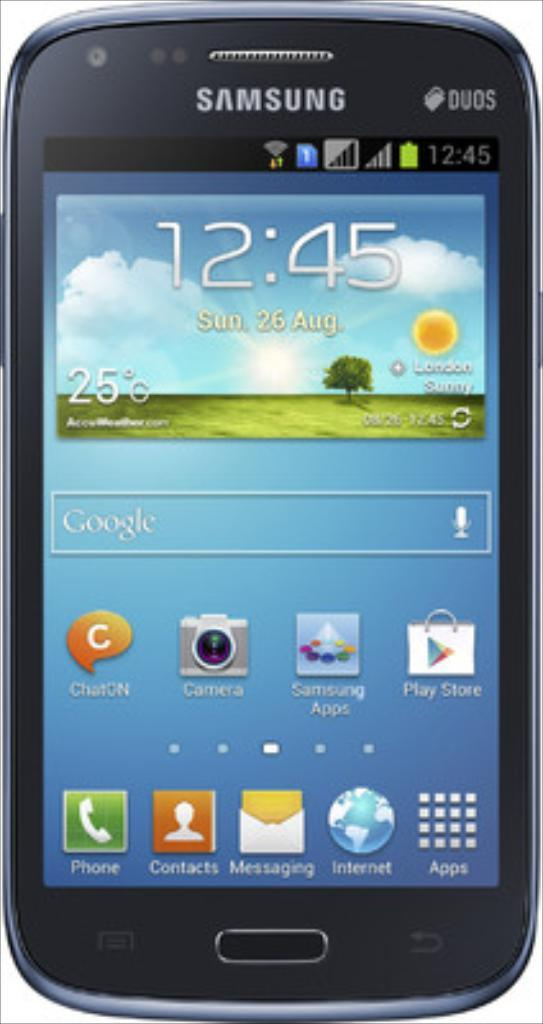<image>
Give a short and clear explanation of the subsequent image. A Samsung phone that says it is 12:45 on Sunday, August 26th. 